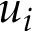Convert formula to latex. <formula><loc_0><loc_0><loc_500><loc_500>u _ { i }</formula> 